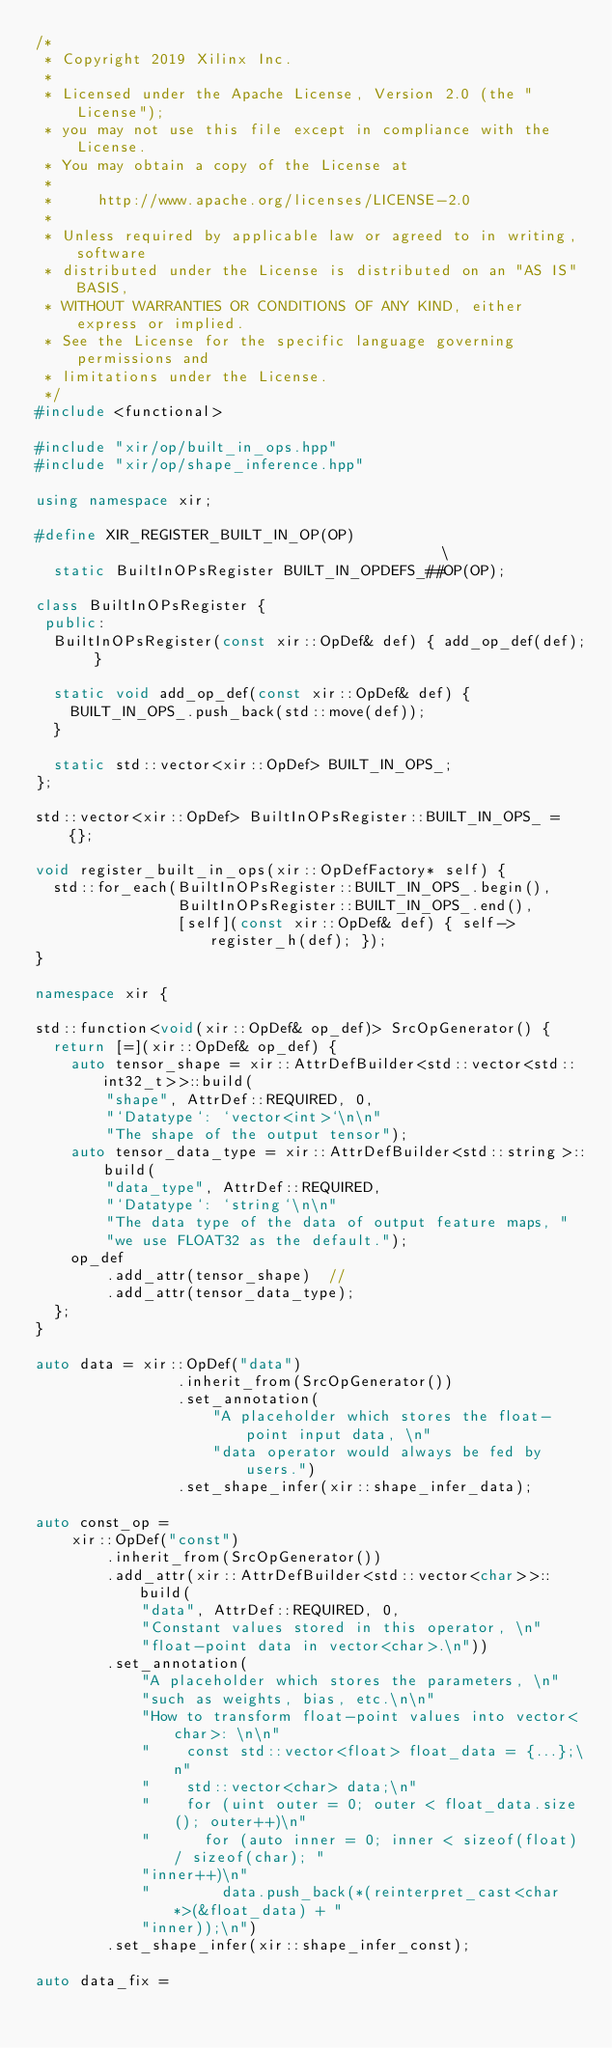<code> <loc_0><loc_0><loc_500><loc_500><_C++_>/*
 * Copyright 2019 Xilinx Inc.
 *
 * Licensed under the Apache License, Version 2.0 (the "License");
 * you may not use this file except in compliance with the License.
 * You may obtain a copy of the License at
 *
 *     http://www.apache.org/licenses/LICENSE-2.0
 *
 * Unless required by applicable law or agreed to in writing, software
 * distributed under the License is distributed on an "AS IS" BASIS,
 * WITHOUT WARRANTIES OR CONDITIONS OF ANY KIND, either express or implied.
 * See the License for the specific language governing permissions and
 * limitations under the License.
 */
#include <functional>

#include "xir/op/built_in_ops.hpp"
#include "xir/op/shape_inference.hpp"

using namespace xir;

#define XIR_REGISTER_BUILT_IN_OP(OP)                                           \
  static BuiltInOPsRegister BUILT_IN_OPDEFS_##OP(OP);

class BuiltInOPsRegister {
 public:
  BuiltInOPsRegister(const xir::OpDef& def) { add_op_def(def); }

  static void add_op_def(const xir::OpDef& def) {
    BUILT_IN_OPS_.push_back(std::move(def));
  }

  static std::vector<xir::OpDef> BUILT_IN_OPS_;
};

std::vector<xir::OpDef> BuiltInOPsRegister::BUILT_IN_OPS_ = {};

void register_built_in_ops(xir::OpDefFactory* self) {
  std::for_each(BuiltInOPsRegister::BUILT_IN_OPS_.begin(),
                BuiltInOPsRegister::BUILT_IN_OPS_.end(),
                [self](const xir::OpDef& def) { self->register_h(def); });
}

namespace xir {

std::function<void(xir::OpDef& op_def)> SrcOpGenerator() {
  return [=](xir::OpDef& op_def) {
    auto tensor_shape = xir::AttrDefBuilder<std::vector<std::int32_t>>::build(
        "shape", AttrDef::REQUIRED, 0,
        "`Datatype`: `vector<int>`\n\n"
        "The shape of the output tensor");
    auto tensor_data_type = xir::AttrDefBuilder<std::string>::build(
        "data_type", AttrDef::REQUIRED,
        "`Datatype`: `string`\n\n"
        "The data type of the data of output feature maps, "
        "we use FLOAT32 as the default.");
    op_def
        .add_attr(tensor_shape)  //
        .add_attr(tensor_data_type);
  };
}

auto data = xir::OpDef("data")
                .inherit_from(SrcOpGenerator())
                .set_annotation(
                    "A placeholder which stores the float-point input data, \n"
                    "data operator would always be fed by users.")
                .set_shape_infer(xir::shape_infer_data);

auto const_op =
    xir::OpDef("const")
        .inherit_from(SrcOpGenerator())
        .add_attr(xir::AttrDefBuilder<std::vector<char>>::build(
            "data", AttrDef::REQUIRED, 0,
            "Constant values stored in this operator, \n"
            "float-point data in vector<char>.\n"))
        .set_annotation(
            "A placeholder which stores the parameters, \n"
            "such as weights, bias, etc.\n\n"
            "How to transform float-point values into vector<char>: \n\n"
            "    const std::vector<float> float_data = {...};\n"
            "    std::vector<char> data;\n"
            "    for (uint outer = 0; outer < float_data.size(); outer++)\n"
            "      for (auto inner = 0; inner < sizeof(float) / sizeof(char); "
            "inner++)\n"
            "        data.push_back(*(reinterpret_cast<char*>(&float_data) + "
            "inner));\n")
        .set_shape_infer(xir::shape_infer_const);

auto data_fix =</code> 